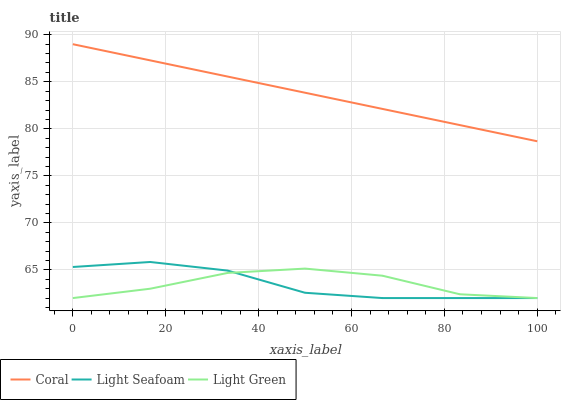Does Light Seafoam have the minimum area under the curve?
Answer yes or no. Yes. Does Coral have the maximum area under the curve?
Answer yes or no. Yes. Does Light Green have the minimum area under the curve?
Answer yes or no. No. Does Light Green have the maximum area under the curve?
Answer yes or no. No. Is Coral the smoothest?
Answer yes or no. Yes. Is Light Green the roughest?
Answer yes or no. Yes. Is Light Seafoam the smoothest?
Answer yes or no. No. Is Light Seafoam the roughest?
Answer yes or no. No. Does Light Seafoam have the lowest value?
Answer yes or no. Yes. Does Coral have the highest value?
Answer yes or no. Yes. Does Light Seafoam have the highest value?
Answer yes or no. No. Is Light Green less than Coral?
Answer yes or no. Yes. Is Coral greater than Light Seafoam?
Answer yes or no. Yes. Does Light Seafoam intersect Light Green?
Answer yes or no. Yes. Is Light Seafoam less than Light Green?
Answer yes or no. No. Is Light Seafoam greater than Light Green?
Answer yes or no. No. Does Light Green intersect Coral?
Answer yes or no. No. 